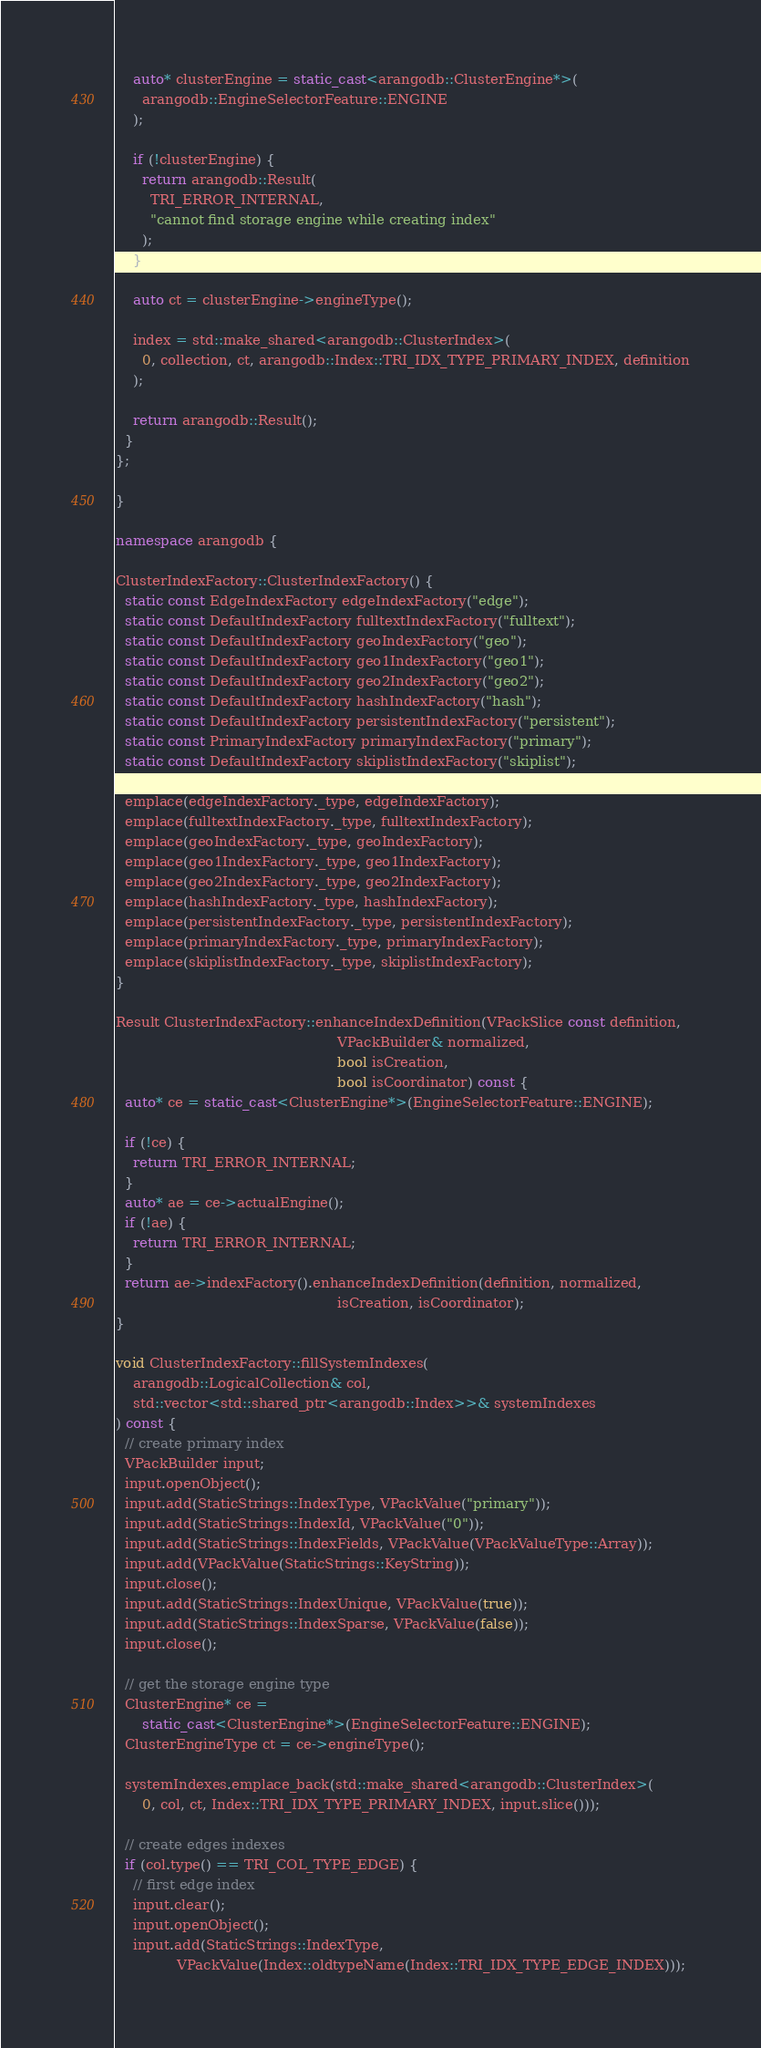Convert code to text. <code><loc_0><loc_0><loc_500><loc_500><_C++_>
    auto* clusterEngine = static_cast<arangodb::ClusterEngine*>(
      arangodb::EngineSelectorFeature::ENGINE
    );

    if (!clusterEngine) {
      return arangodb::Result(
        TRI_ERROR_INTERNAL,
        "cannot find storage engine while creating index"
      );
    }

    auto ct = clusterEngine->engineType();

    index = std::make_shared<arangodb::ClusterIndex>(
      0, collection, ct, arangodb::Index::TRI_IDX_TYPE_PRIMARY_INDEX, definition
    );

    return arangodb::Result();
  }
};

}

namespace arangodb {

ClusterIndexFactory::ClusterIndexFactory() {
  static const EdgeIndexFactory edgeIndexFactory("edge");
  static const DefaultIndexFactory fulltextIndexFactory("fulltext");
  static const DefaultIndexFactory geoIndexFactory("geo");
  static const DefaultIndexFactory geo1IndexFactory("geo1");
  static const DefaultIndexFactory geo2IndexFactory("geo2");
  static const DefaultIndexFactory hashIndexFactory("hash");
  static const DefaultIndexFactory persistentIndexFactory("persistent");
  static const PrimaryIndexFactory primaryIndexFactory("primary");
  static const DefaultIndexFactory skiplistIndexFactory("skiplist");

  emplace(edgeIndexFactory._type, edgeIndexFactory);
  emplace(fulltextIndexFactory._type, fulltextIndexFactory);
  emplace(geoIndexFactory._type, geoIndexFactory);
  emplace(geo1IndexFactory._type, geo1IndexFactory);
  emplace(geo2IndexFactory._type, geo2IndexFactory);
  emplace(hashIndexFactory._type, hashIndexFactory);
  emplace(persistentIndexFactory._type, persistentIndexFactory);
  emplace(primaryIndexFactory._type, primaryIndexFactory);
  emplace(skiplistIndexFactory._type, skiplistIndexFactory);
}

Result ClusterIndexFactory::enhanceIndexDefinition(VPackSlice const definition,
                                                   VPackBuilder& normalized,
                                                   bool isCreation,
                                                   bool isCoordinator) const {
  auto* ce = static_cast<ClusterEngine*>(EngineSelectorFeature::ENGINE);
  
  if (!ce) {
    return TRI_ERROR_INTERNAL;
  }
  auto* ae = ce->actualEngine();
  if (!ae) {
    return TRI_ERROR_INTERNAL;
  }
  return ae->indexFactory().enhanceIndexDefinition(definition, normalized,
                                                   isCreation, isCoordinator);
}

void ClusterIndexFactory::fillSystemIndexes(
    arangodb::LogicalCollection& col,
    std::vector<std::shared_ptr<arangodb::Index>>& systemIndexes
) const {
  // create primary index
  VPackBuilder input;
  input.openObject();
  input.add(StaticStrings::IndexType, VPackValue("primary"));
  input.add(StaticStrings::IndexId, VPackValue("0"));
  input.add(StaticStrings::IndexFields, VPackValue(VPackValueType::Array));
  input.add(VPackValue(StaticStrings::KeyString));
  input.close();
  input.add(StaticStrings::IndexUnique, VPackValue(true));
  input.add(StaticStrings::IndexSparse, VPackValue(false));
  input.close();

  // get the storage engine type
  ClusterEngine* ce =
      static_cast<ClusterEngine*>(EngineSelectorFeature::ENGINE);
  ClusterEngineType ct = ce->engineType();

  systemIndexes.emplace_back(std::make_shared<arangodb::ClusterIndex>(
      0, col, ct, Index::TRI_IDX_TYPE_PRIMARY_INDEX, input.slice()));

  // create edges indexes
  if (col.type() == TRI_COL_TYPE_EDGE) {
    // first edge index
    input.clear();
    input.openObject();
    input.add(StaticStrings::IndexType,
              VPackValue(Index::oldtypeName(Index::TRI_IDX_TYPE_EDGE_INDEX)));</code> 